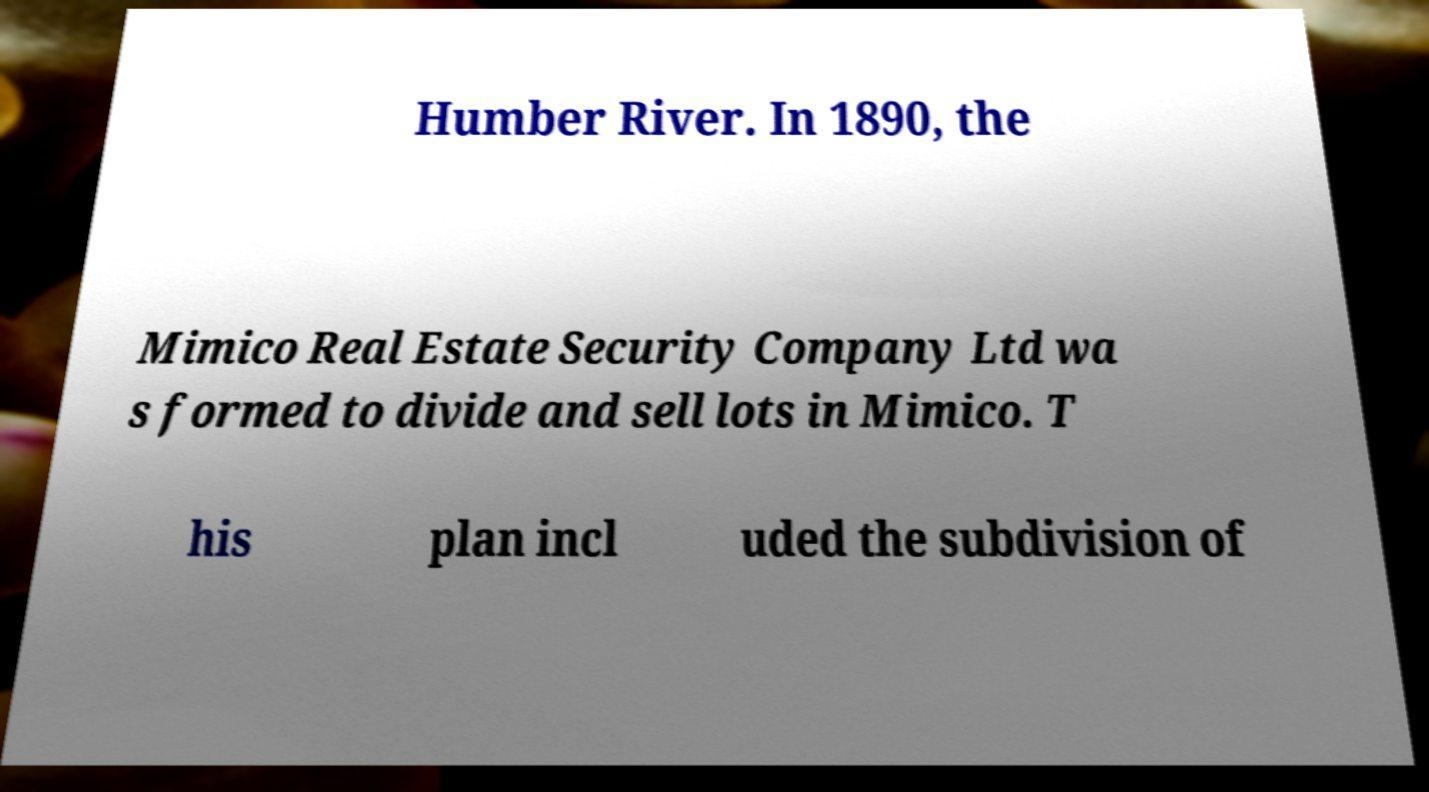What messages or text are displayed in this image? I need them in a readable, typed format. Humber River. In 1890, the Mimico Real Estate Security Company Ltd wa s formed to divide and sell lots in Mimico. T his plan incl uded the subdivision of 